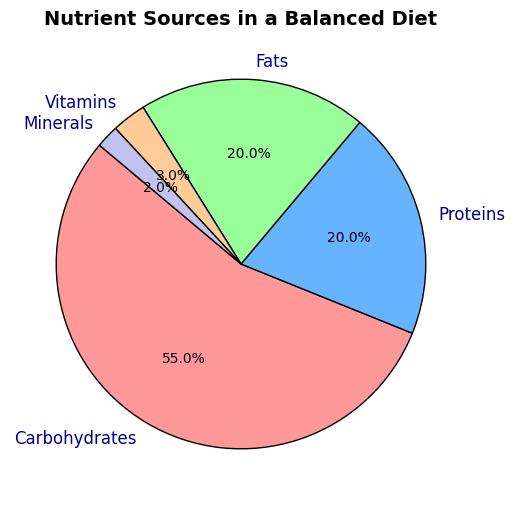What's the percentage of Carbohydrates in the diet? The pie chart shows that the Carbohydrates section is labeled with a percentage value. Simply refer to this label on the pie chart.
Answer: 55% What is the total percentage of Proteins and Fats in the diet? The pie chart shows the percentages for Proteins and Fats as 20% each. Adding these two values together gives 20% + 20% = 40%.
Answer: 40% Which nutrient source has the lowest percentage in the diet? The pie chart lists all nutrient percentages. By comparing these values, Minerals have the lowest percentage at 2%.
Answer: Minerals Are Vitamins or Minerals represented by a larger section in the pie chart? Visually compare the sizes of the sections labeled "Vitamins" and "Minerals". The pie chart shows Vitamins at 3% and Minerals at 2%. 3% is greater than 2%.
Answer: Vitamins What is the combined percentage of Vitamins, Minerals, and Fats? The pie chart labels show Vitamins at 3%, Minerals at 2%, and Fats at 20%. Adding these together gives 3% + 2% + 20% = 25%.
Answer: 25% Which nutrient source is represented by the largest section in the pie chart? By looking at the pie chart, the largest section is determined by comparing all slices. Carbohydrates are the largest at 55%.
Answer: Carbohydrates What's the difference in percentage between Carbohydrates and Proteins? The percentages for Carbohydrates and Proteins are 55% and 20%, respectively. The difference is calculated as 55% - 20% = 35%.
Answer: 35% What percentage of the diet is not composed of Carbohydrates? Subtract the percentage of Carbohydrates from 100%: 100% - 55% = 45%.
Answer: 45% Are Proteins and Fats equal in their percentage representation? The pie chart shows that both Proteins and Fats have a percentage value of 20%.
Answer: Yes Which nutrients combined make up less than 10% of the diet? Add the percentages of Vitamins and Minerals (3% + 2% = 5%), which is less than 10%. No other combination of nutrients under 10% is possible.
Answer: Vitamins and Minerals 